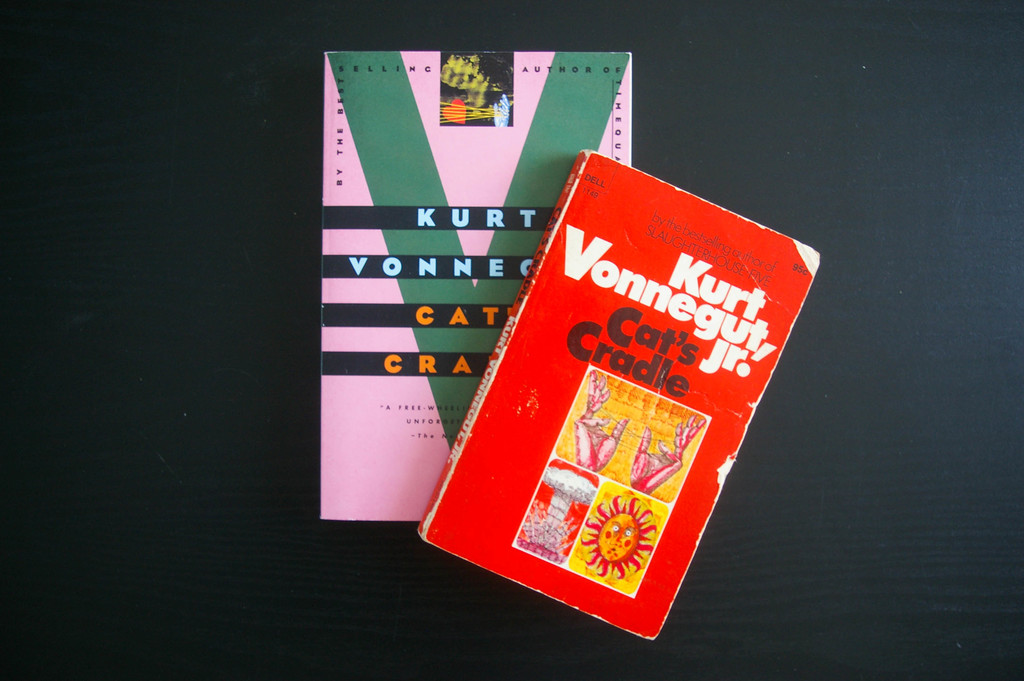Provide a one-sentence caption for the provided image. The image shows two iconic novels by Kurt Vonnegut Jr., 'Cat's Cradle' and another, resting side-by-side on a sleek black surface, the worn covers hinting at the cherished tales within. 